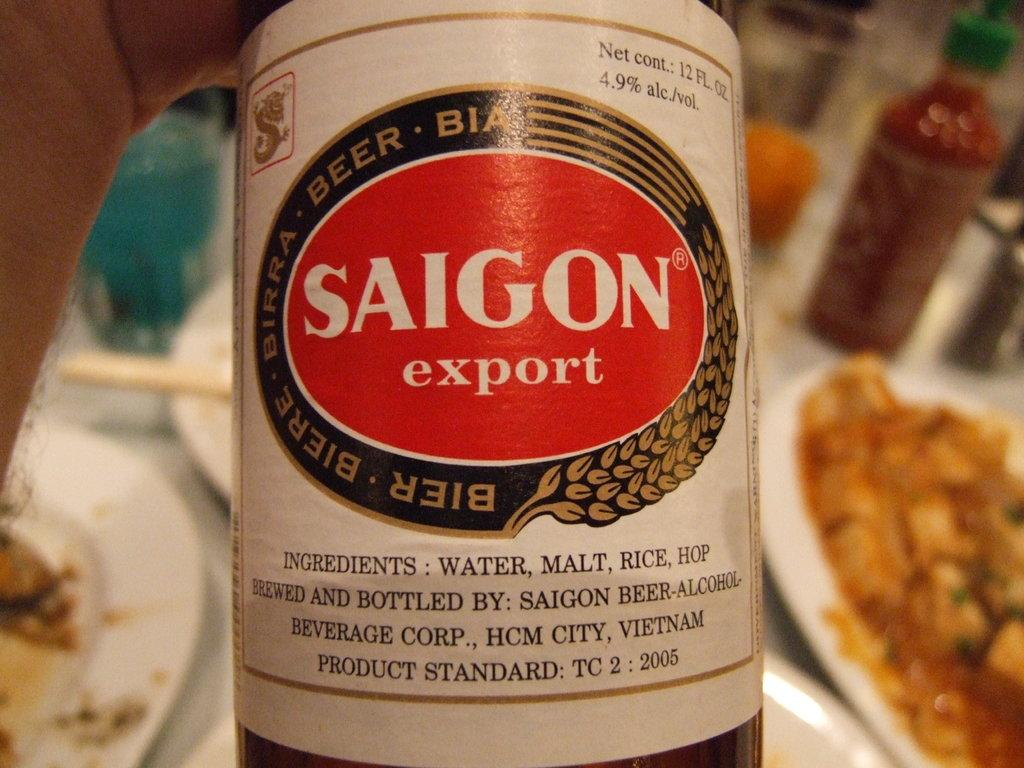<image>
Provide a brief description of the given image. A label for Saigon export is red with white lettering. 